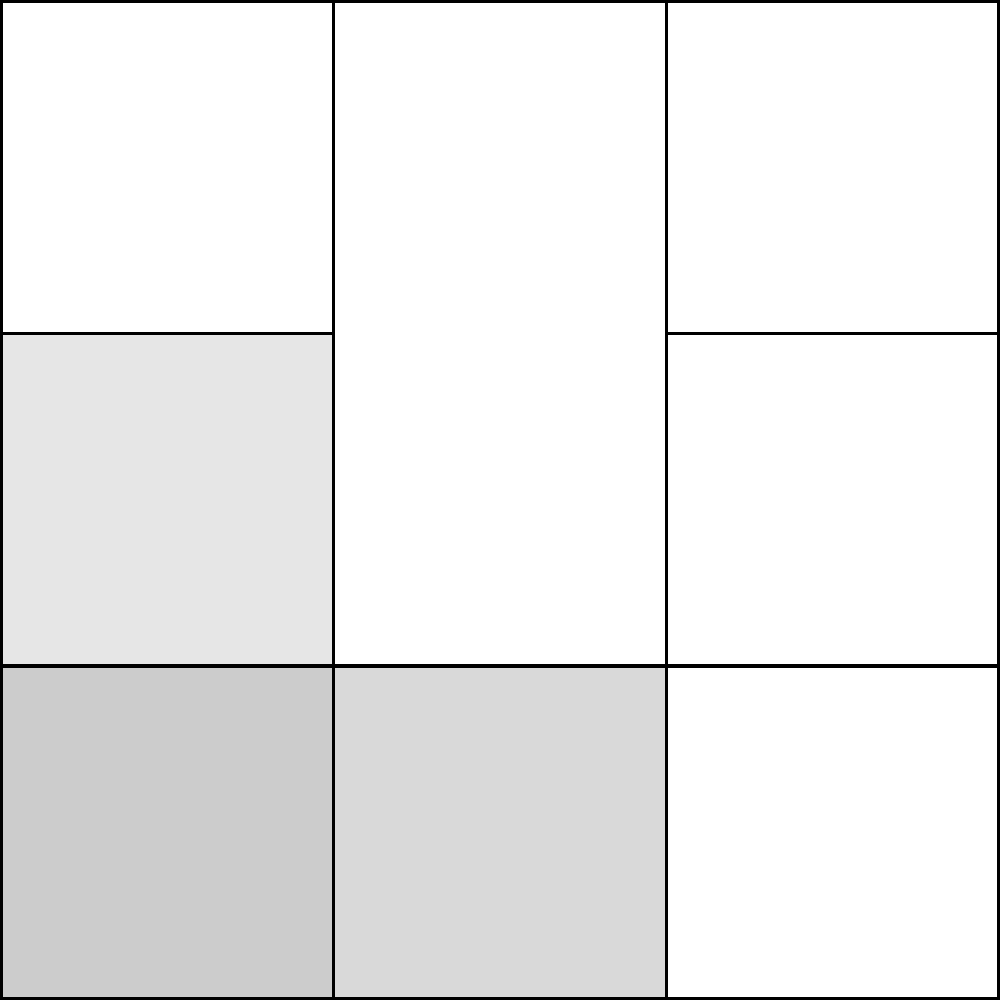As an entrepreneur who has likely encountered complex business challenges, consider this jigsaw puzzle representing various aspects of a project. Which piece is missing from the puzzle, and how would its addition complete the overall pattern? To solve this puzzle, let's approach it systematically:

1. Observe the overall pattern: The puzzle is a 3x3 grid of square pieces.

2. Identify the filled pieces: We can see that 8 out of 9 pieces are filled with different shades of gray.

3. Locate the missing piece: The empty space is in the middle of the puzzle, at position (1,1) in a coordinate system where (0,0) is the bottom-left corner.

4. Analyze the surrounding pieces:
   - The piece to the left is lighter than the one above it.
   - The piece to the right is darker than the one below it.
   - There's a general pattern of alternating light and dark pieces.

5. Deduce the characteristics of the missing piece:
   - It should be of medium shade to maintain the alternating pattern.
   - Its shade should be between the pieces above and below, and between the pieces to the left and right.

6. Relate to business context: In a project, this middle piece could represent a crucial connecting element that brings together different aspects (represented by surrounding pieces) of the business venture.
Answer: The missing piece is in the center (position 1,1), with a medium gray shade. 